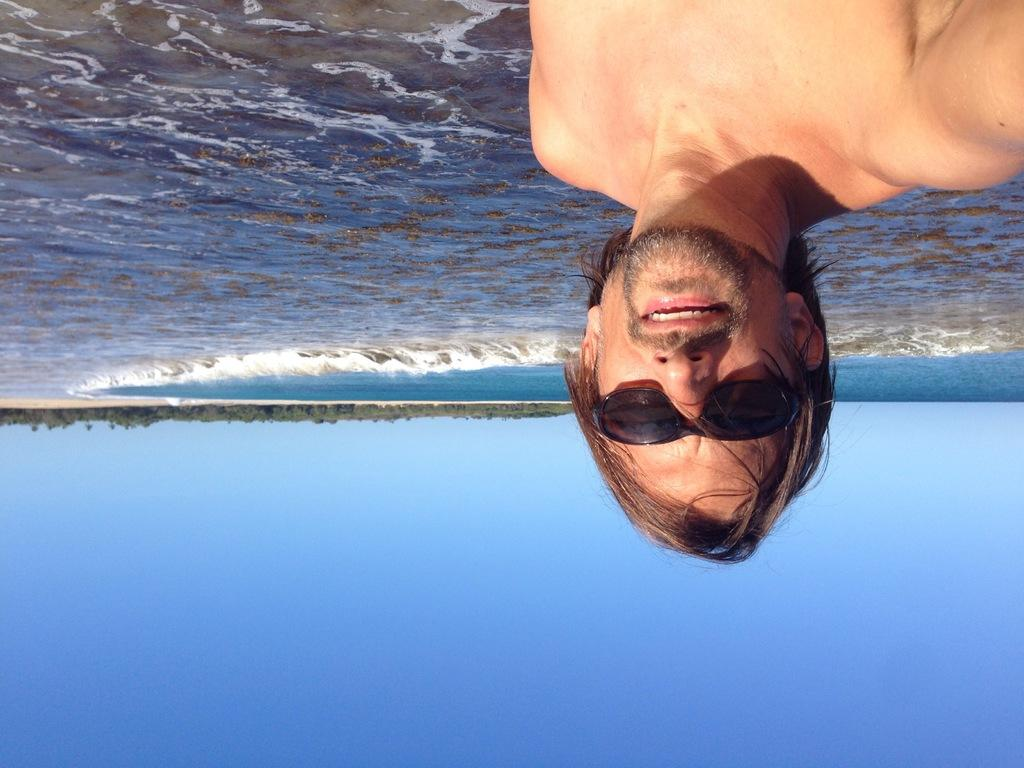What can be seen in the image? There is a person in the image. Can you describe the person's appearance? The person is wearing black color glasses. What else is visible in the image besides the person? There is water and trees visible in the image. How would you describe the sky in the image? The sky is blue and white in color. What type of collar can be seen on the person in the image? There is no collar visible on the person in the image. Can you describe the wilderness setting in the image? There is no wilderness setting in the image; it features a person on the floor with water and trees visible in the background. What verse is being recited by the person in the image? There is no indication that the person is reciting a verse in the image. 